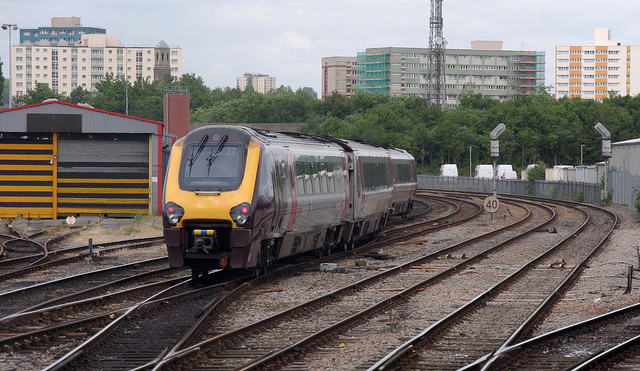Please transcribe the text information in this image. 40 